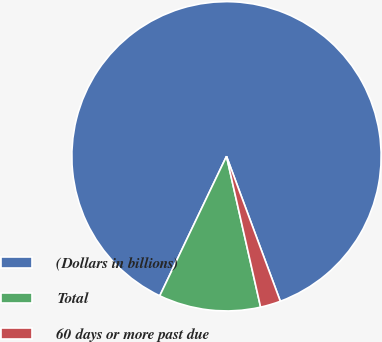Convert chart. <chart><loc_0><loc_0><loc_500><loc_500><pie_chart><fcel>(Dollars in billions)<fcel>Total<fcel>60 days or more past due<nl><fcel>87.24%<fcel>10.64%<fcel>2.12%<nl></chart> 